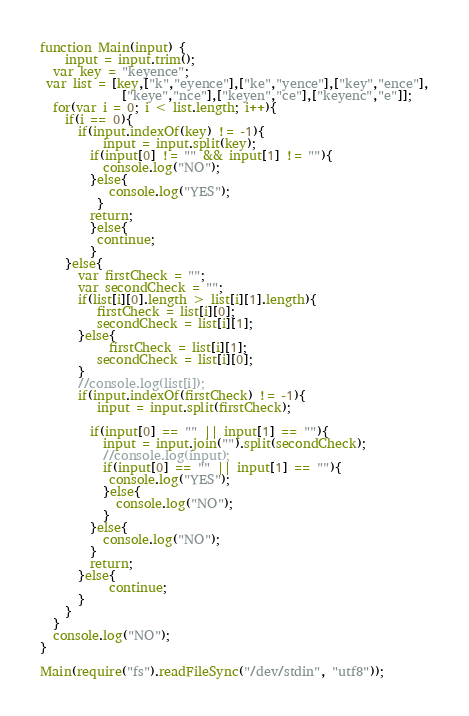Convert code to text. <code><loc_0><loc_0><loc_500><loc_500><_JavaScript_>function Main(input) {
	input = input.trim();
  var key = "keyence";
 var list = [key,["k","eyence"],["ke","yence"],["key","ence"],
             ["keye","nce"],["keyen","ce"],["keyenc","e"]];
  for(var i = 0; i < list.length; i++){
    if(i == 0){
      if(input.indexOf(key) != -1){
     	  input = input.split(key);
      	if(input[0] != "" && input[1] != ""){
       	  console.log("NO");
      	}else{
       	   console.log("YES");
     	 }
      	return;
    	}else{
         continue; 
        }
    }else{
      var firstCheck = "";
      var secondCheck = "";
      if(list[i][0].length > list[i][1].length){
         firstCheck = list[i][0];
      	 secondCheck = list[i][1];
      }else{
           firstCheck = list[i][1];
      	 secondCheck = list[i][0];
      }
      //console.log(list[i]);
      if(input.indexOf(firstCheck) != -1){
         input = input.split(firstCheck);
        
        if(input[0] == "" || input[1] == ""){
          input = input.join("").split(secondCheck);
          //console.log(input);
          if(input[0] == "" || input[1] == ""){
           console.log("YES");
          }else{
            console.log("NO");
          }
        }else{
          console.log("NO");
        }
        return;
      }else{
           continue;
      }
    }
  }
  console.log("NO");
}

Main(require("fs").readFileSync("/dev/stdin", "utf8"));
</code> 